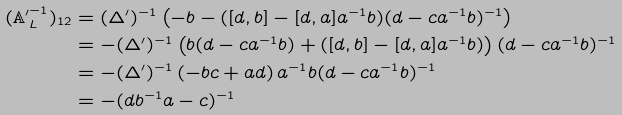<formula> <loc_0><loc_0><loc_500><loc_500>( \mathbb { A ^ { \prime } } ^ { - 1 } _ { L } ) _ { 1 2 } & = ( \Delta ^ { \prime } ) ^ { - 1 } \left ( - b - ( [ d , b ] - [ d , a ] a ^ { - 1 } b ) ( d - c a ^ { - 1 } b ) ^ { - 1 } \right ) \\ & = - ( \Delta ^ { \prime } ) ^ { - 1 } \left ( b ( d - c a ^ { - 1 } b ) + ( [ d , b ] - [ d , a ] a ^ { - 1 } b ) \right ) ( d - c a ^ { - 1 } b ) ^ { - 1 } \\ & = - ( \Delta ^ { \prime } ) ^ { - 1 } \left ( - b c + a d \right ) a ^ { - 1 } b ( d - c a ^ { - 1 } b ) ^ { - 1 } \\ & = - ( d b ^ { - 1 } a - c ) ^ { - 1 }</formula> 